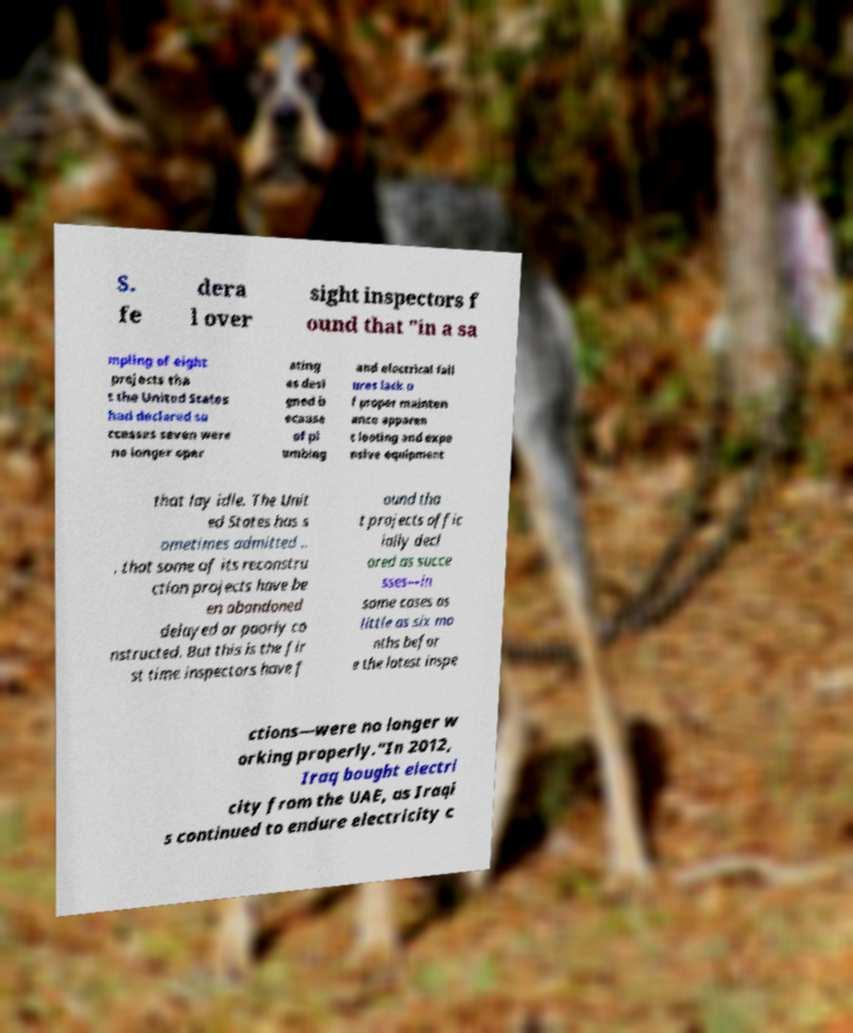Please identify and transcribe the text found in this image. S. fe dera l over sight inspectors f ound that "in a sa mpling of eight projects tha t the United States had declared su ccesses seven were no longer oper ating as desi gned b ecause of pl umbing and electrical fail ures lack o f proper mainten ance apparen t looting and expe nsive equipment that lay idle. The Unit ed States has s ometimes admitted .. . that some of its reconstru ction projects have be en abandoned delayed or poorly co nstructed. But this is the fir st time inspectors have f ound tha t projects offic ially decl ared as succe sses—in some cases as little as six mo nths befor e the latest inspe ctions—were no longer w orking properly."In 2012, Iraq bought electri city from the UAE, as Iraqi s continued to endure electricity c 